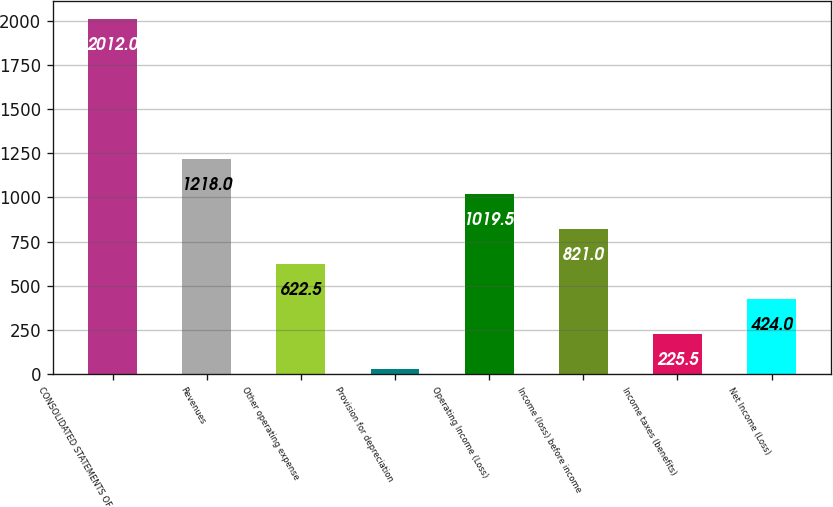Convert chart. <chart><loc_0><loc_0><loc_500><loc_500><bar_chart><fcel>CONSOLIDATED STATEMENTS OF<fcel>Revenues<fcel>Other operating expense<fcel>Provision for depreciation<fcel>Operating Income (Loss)<fcel>Income (loss) before income<fcel>Income taxes (benefits)<fcel>Net Income (Loss)<nl><fcel>2012<fcel>1218<fcel>622.5<fcel>27<fcel>1019.5<fcel>821<fcel>225.5<fcel>424<nl></chart> 